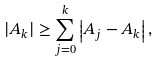Convert formula to latex. <formula><loc_0><loc_0><loc_500><loc_500>| A _ { k } | \geq \sum _ { j = 0 } ^ { k } \left | A _ { j } - A _ { k } \right | ,</formula> 